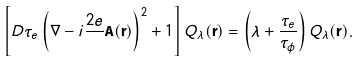<formula> <loc_0><loc_0><loc_500><loc_500>\left [ D \tau _ { e } \left ( \nabla - i \frac { 2 e } { } { \mathbf A } ( { \mathbf r } ) \right ) ^ { 2 } + 1 \right ] Q _ { \lambda } ( { \mathbf r } ) = \left ( \lambda + \frac { \tau _ { e } } { \tau _ { \phi } } \right ) Q _ { \lambda } ( { \mathbf r } ) .</formula> 